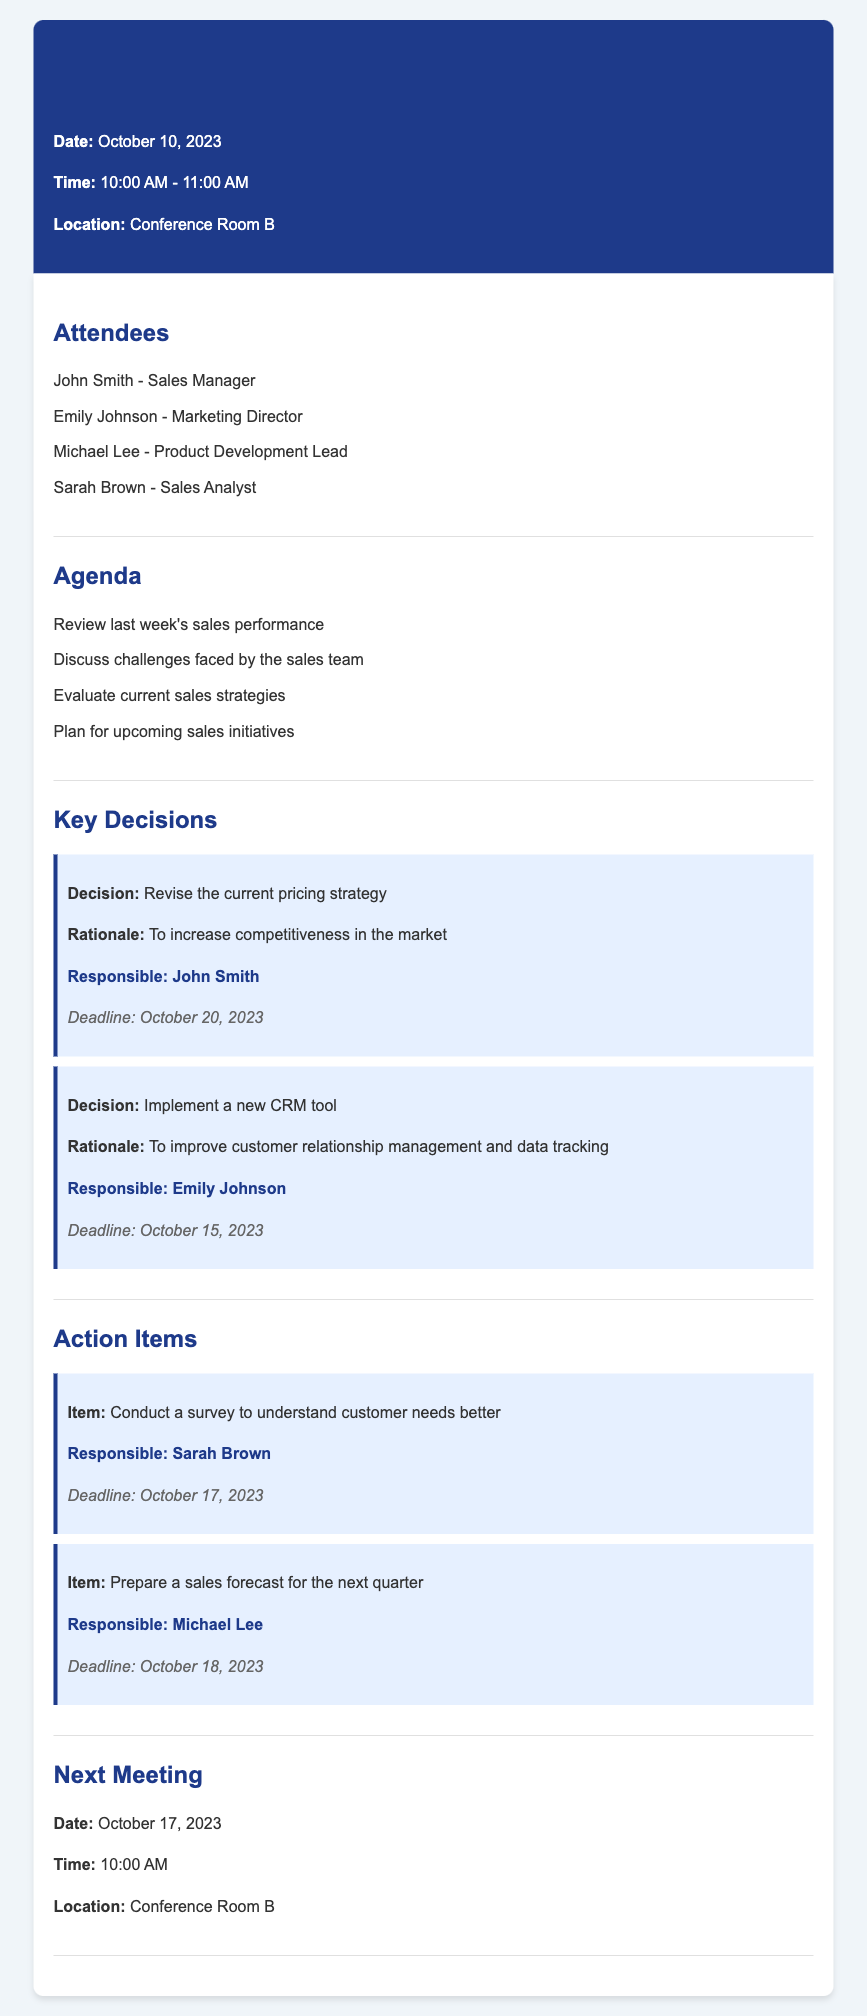What is the date of the memo? The date of the memo is stated in the header section of the document.
Answer: October 10, 2023 Who are the attendees of the meeting? The attendees are listed under the attendees section of the document in a bullet point format.
Answer: John Smith, Emily Johnson, Michael Lee, Sarah Brown What is the deadline for the new CRM tool implementation? The deadline for this action is specified in the decisions section alongside the responsible person.
Answer: October 15, 2023 What is one major action item assigned to Sarah Brown? The action items are detailed in their own section, with specific responsibilities outlined.
Answer: Conduct a survey to understand customer needs better What is the rationale behind revising the current pricing strategy? The rationale is provided alongside the decision in the key decisions section of the document.
Answer: To increase competitiveness in the market Who is responsible for preparing the sales forecast? The responsible person for this action item is mentioned in the corresponding action item description.
Answer: Michael Lee What time will the next meeting take place? The time of the next meeting is specified in the section dedicated to future meetings.
Answer: 10:00 AM What is one of the agenda items for the meeting? The agenda items are listed and provide insights into the focus of the meeting.
Answer: Review last week's sales performance 